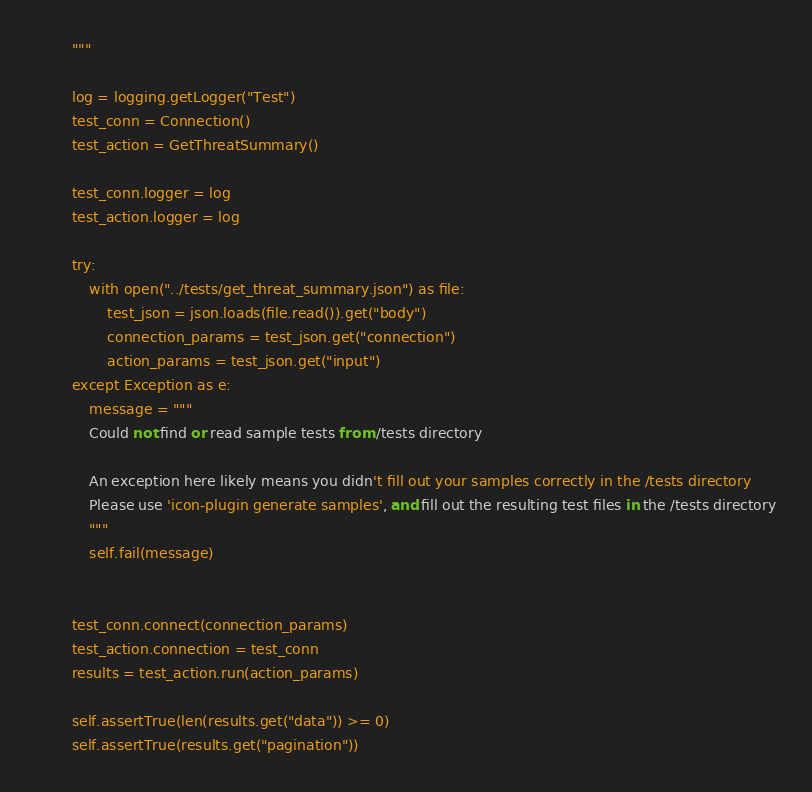Convert code to text. <code><loc_0><loc_0><loc_500><loc_500><_Python_>        """

        log = logging.getLogger("Test")
        test_conn = Connection()
        test_action = GetThreatSummary()

        test_conn.logger = log
        test_action.logger = log

        try:
            with open("../tests/get_threat_summary.json") as file:
                test_json = json.loads(file.read()).get("body")
                connection_params = test_json.get("connection")
                action_params = test_json.get("input")
        except Exception as e:
            message = """
            Could not find or read sample tests from /tests directory
            
            An exception here likely means you didn't fill out your samples correctly in the /tests directory 
            Please use 'icon-plugin generate samples', and fill out the resulting test files in the /tests directory
            """
            self.fail(message)


        test_conn.connect(connection_params)
        test_action.connection = test_conn
        results = test_action.run(action_params)

        self.assertTrue(len(results.get("data")) >= 0)
        self.assertTrue(results.get("pagination"))
</code> 